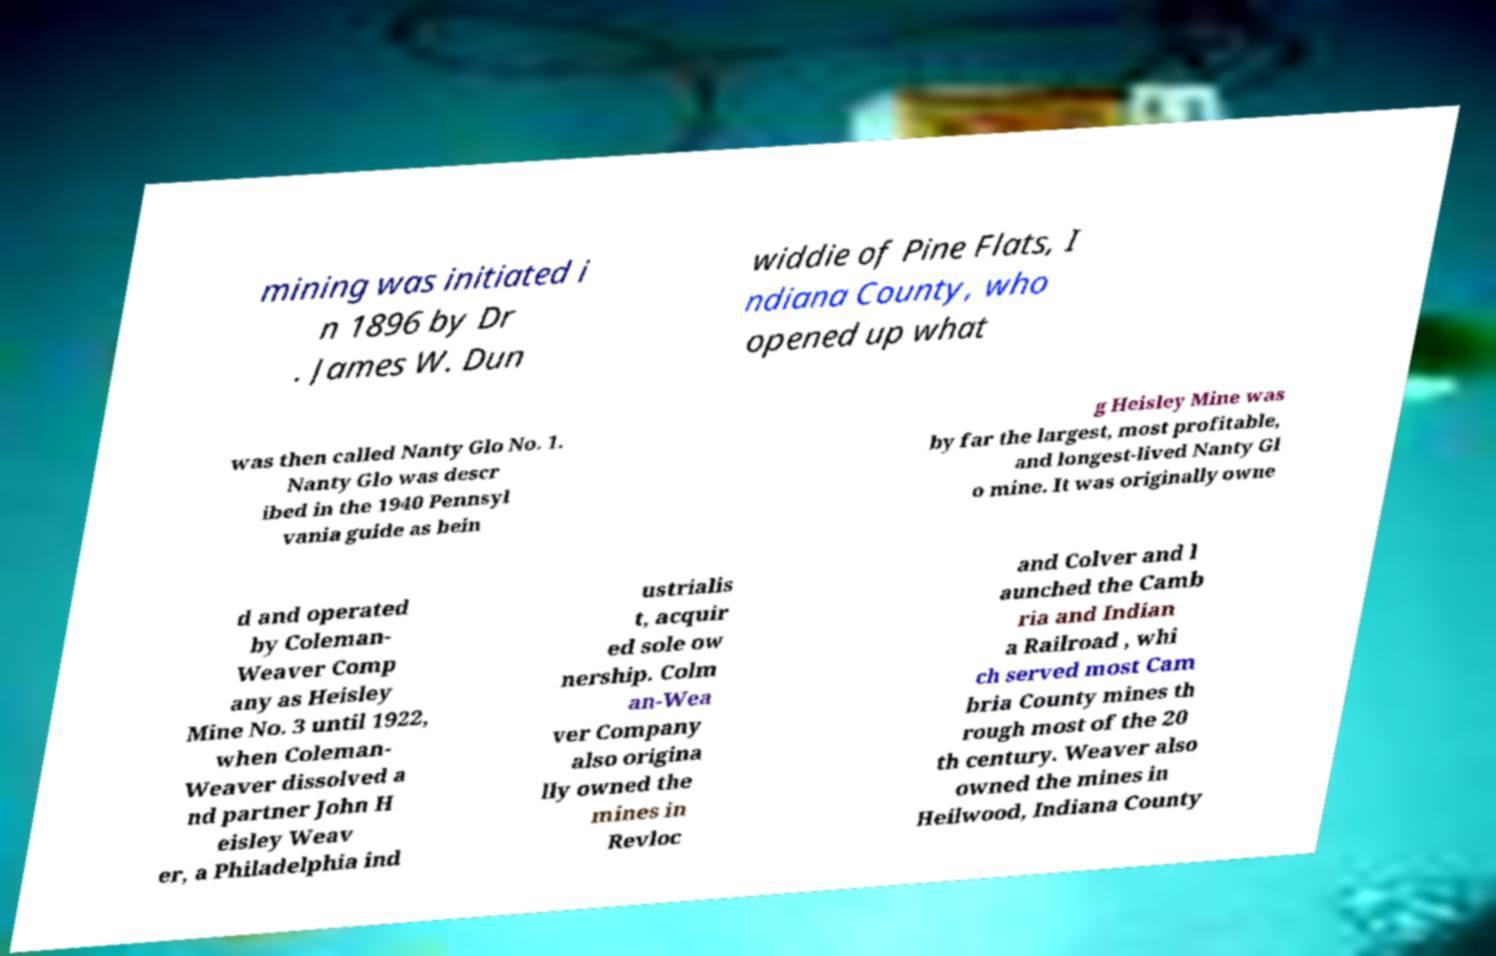For documentation purposes, I need the text within this image transcribed. Could you provide that? mining was initiated i n 1896 by Dr . James W. Dun widdie of Pine Flats, I ndiana County, who opened up what was then called Nanty Glo No. 1. Nanty Glo was descr ibed in the 1940 Pennsyl vania guide as bein g Heisley Mine was by far the largest, most profitable, and longest-lived Nanty Gl o mine. It was originally owne d and operated by Coleman- Weaver Comp any as Heisley Mine No. 3 until 1922, when Coleman- Weaver dissolved a nd partner John H eisley Weav er, a Philadelphia ind ustrialis t, acquir ed sole ow nership. Colm an-Wea ver Company also origina lly owned the mines in Revloc and Colver and l aunched the Camb ria and Indian a Railroad , whi ch served most Cam bria County mines th rough most of the 20 th century. Weaver also owned the mines in Heilwood, Indiana County 